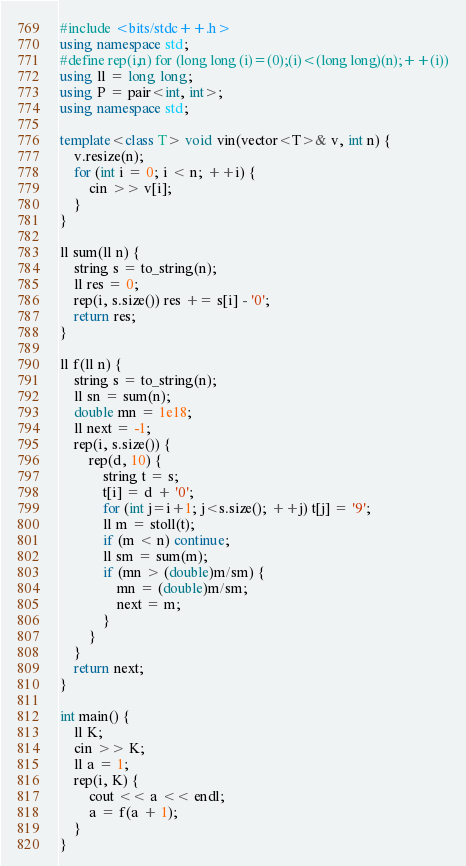Convert code to text. <code><loc_0><loc_0><loc_500><loc_500><_C++_>#include <bits/stdc++.h>
using namespace std;
#define rep(i,n) for (long long (i)=(0);(i)<(long long)(n);++(i))
using ll = long long;
using P = pair<int, int>;
using namespace std;

template<class T> void vin(vector<T>& v, int n) {
    v.resize(n);
    for (int i = 0; i < n; ++i) {
        cin >> v[i];
    }
}

ll sum(ll n) {
    string s = to_string(n);
    ll res = 0;
    rep(i, s.size()) res += s[i] - '0';
    return res;
}

ll f(ll n) {
    string s = to_string(n);
    ll sn = sum(n);
    double mn = 1e18;
    ll next = -1;
    rep(i, s.size()) {
        rep(d, 10) {
            string t = s;
            t[i] = d + '0';
            for (int j=i+1; j<s.size(); ++j) t[j] = '9';
            ll m = stoll(t);
            if (m < n) continue;
            ll sm = sum(m);
            if (mn > (double)m/sm) {
                mn = (double)m/sm;
                next = m;
            }
        }
    }
    return next;
}

int main() {
    ll K;
    cin >> K;
    ll a = 1;
    rep(i, K) {
        cout << a << endl;
        a = f(a + 1);
    }
}
</code> 